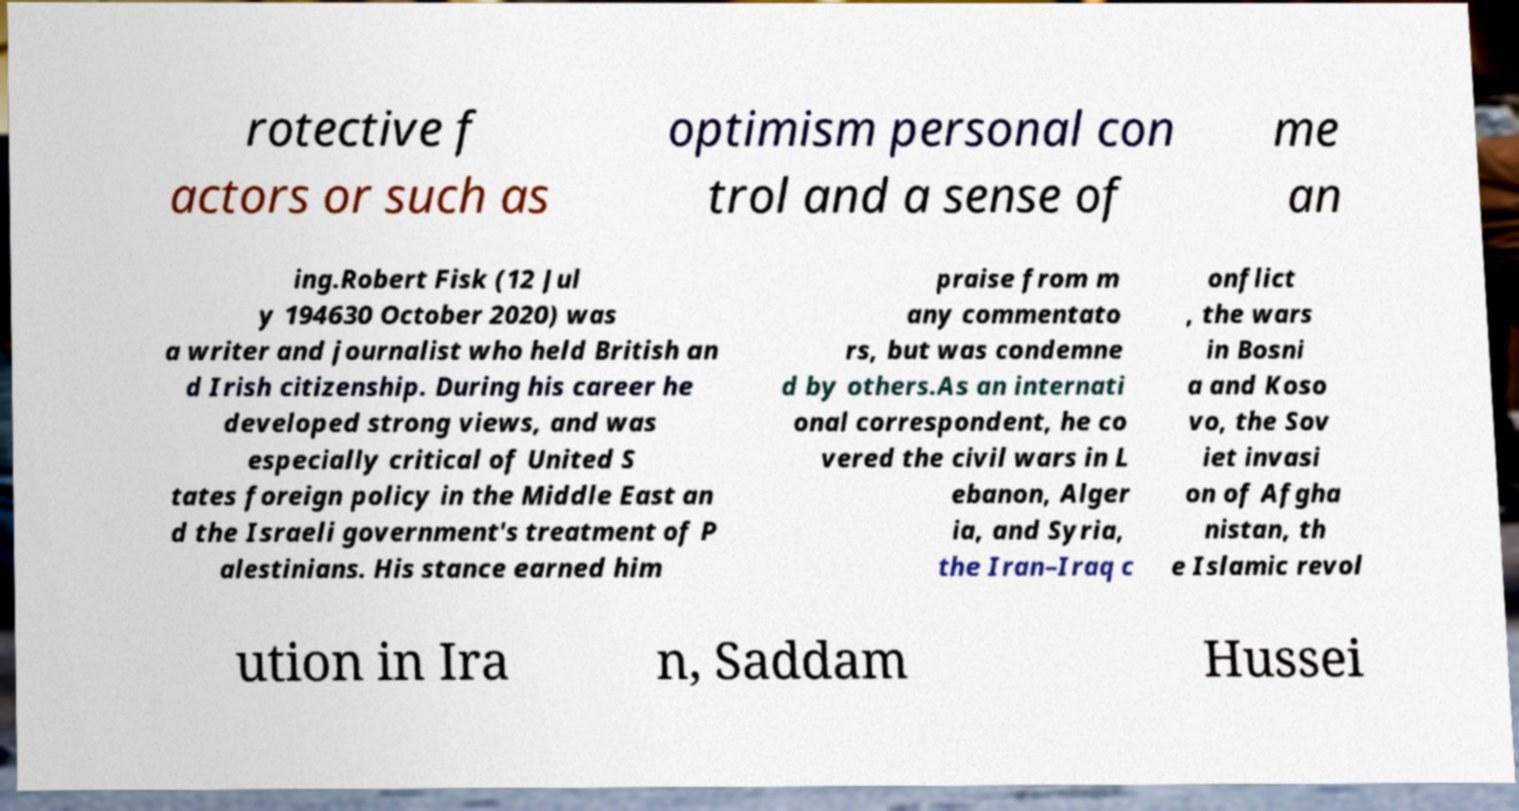For documentation purposes, I need the text within this image transcribed. Could you provide that? rotective f actors or such as optimism personal con trol and a sense of me an ing.Robert Fisk (12 Jul y 194630 October 2020) was a writer and journalist who held British an d Irish citizenship. During his career he developed strong views, and was especially critical of United S tates foreign policy in the Middle East an d the Israeli government's treatment of P alestinians. His stance earned him praise from m any commentato rs, but was condemne d by others.As an internati onal correspondent, he co vered the civil wars in L ebanon, Alger ia, and Syria, the Iran–Iraq c onflict , the wars in Bosni a and Koso vo, the Sov iet invasi on of Afgha nistan, th e Islamic revol ution in Ira n, Saddam Hussei 